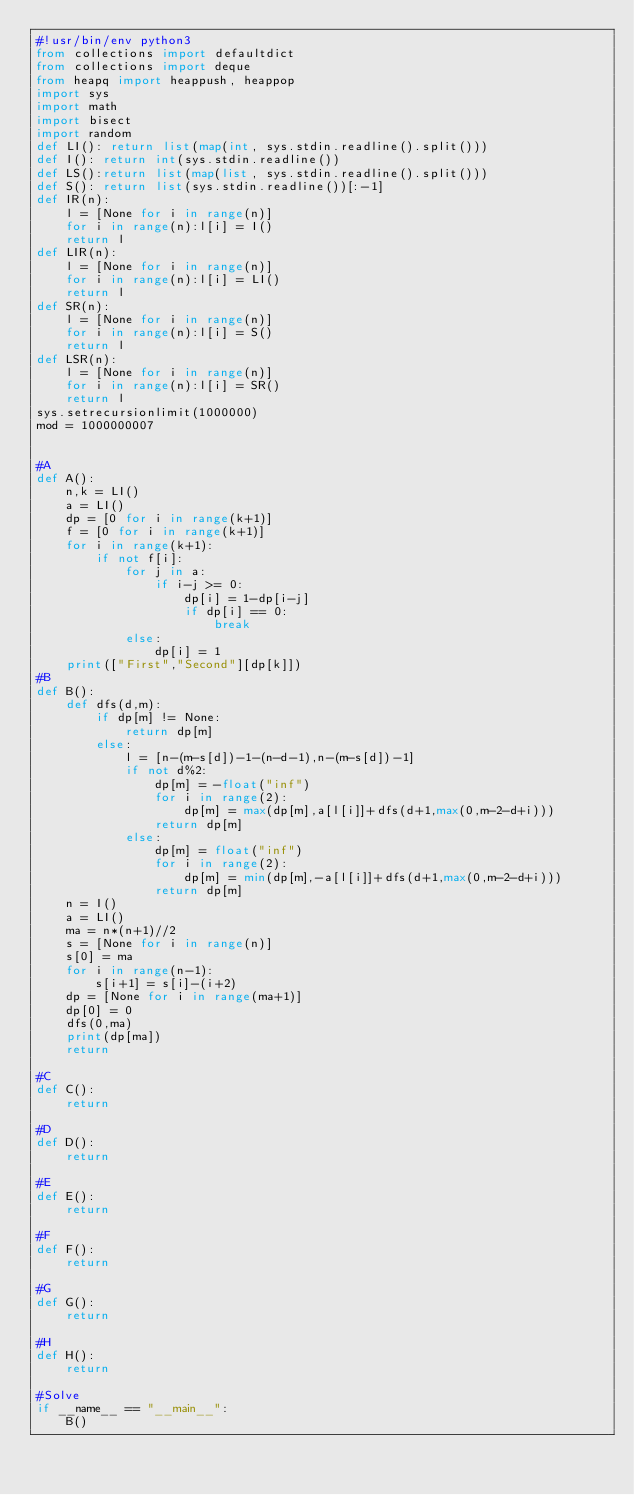Convert code to text. <code><loc_0><loc_0><loc_500><loc_500><_Python_>#!usr/bin/env python3
from collections import defaultdict
from collections import deque
from heapq import heappush, heappop
import sys
import math
import bisect
import random
def LI(): return list(map(int, sys.stdin.readline().split()))
def I(): return int(sys.stdin.readline())
def LS():return list(map(list, sys.stdin.readline().split()))
def S(): return list(sys.stdin.readline())[:-1]
def IR(n):
    l = [None for i in range(n)]
    for i in range(n):l[i] = I()
    return l
def LIR(n):
    l = [None for i in range(n)]
    for i in range(n):l[i] = LI()
    return l
def SR(n):
    l = [None for i in range(n)]
    for i in range(n):l[i] = S()
    return l
def LSR(n):
    l = [None for i in range(n)]
    for i in range(n):l[i] = SR()
    return l
sys.setrecursionlimit(1000000)
mod = 1000000007


#A
def A():
    n,k = LI()
    a = LI()
    dp = [0 for i in range(k+1)]
    f = [0 for i in range(k+1)]
    for i in range(k+1):
        if not f[i]:
            for j in a:
                if i-j >= 0:
                    dp[i] = 1-dp[i-j]
                    if dp[i] == 0:
                        break
            else:
                dp[i] = 1
    print(["First","Second"][dp[k]])
#B
def B():
    def dfs(d,m):
        if dp[m] != None:
            return dp[m]
        else:
            l = [n-(m-s[d])-1-(n-d-1),n-(m-s[d])-1]
            if not d%2:
                dp[m] = -float("inf")
                for i in range(2):
                    dp[m] = max(dp[m],a[l[i]]+dfs(d+1,max(0,m-2-d+i)))
                return dp[m]
            else:
                dp[m] = float("inf")
                for i in range(2):
                    dp[m] = min(dp[m],-a[l[i]]+dfs(d+1,max(0,m-2-d+i)))
                return dp[m]
    n = I()
    a = LI()
    ma = n*(n+1)//2
    s = [None for i in range(n)]
    s[0] = ma
    for i in range(n-1):
        s[i+1] = s[i]-(i+2)
    dp = [None for i in range(ma+1)]
    dp[0] = 0
    dfs(0,ma)
    print(dp[ma])
    return

#C
def C():
    return

#D
def D():
    return

#E
def E():
    return

#F
def F():
    return

#G
def G():
    return

#H
def H():
    return

#Solve
if __name__ == "__main__":
    B()
</code> 